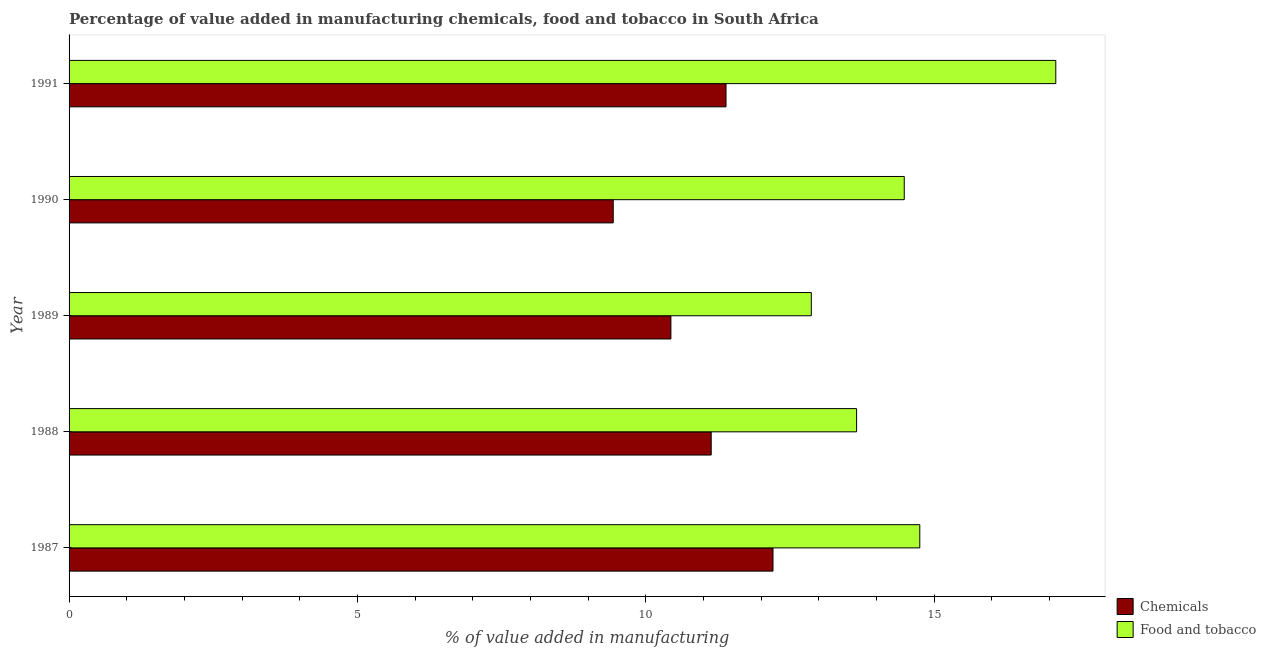How many different coloured bars are there?
Provide a succinct answer. 2. How many bars are there on the 4th tick from the bottom?
Provide a short and direct response. 2. In how many cases, is the number of bars for a given year not equal to the number of legend labels?
Provide a succinct answer. 0. What is the value added by manufacturing food and tobacco in 1989?
Offer a very short reply. 12.87. Across all years, what is the maximum value added by  manufacturing chemicals?
Keep it short and to the point. 12.21. Across all years, what is the minimum value added by  manufacturing chemicals?
Your answer should be compact. 9.44. In which year was the value added by  manufacturing chemicals maximum?
Make the answer very short. 1987. In which year was the value added by  manufacturing chemicals minimum?
Ensure brevity in your answer.  1990. What is the total value added by  manufacturing chemicals in the graph?
Your answer should be very brief. 54.6. What is the difference between the value added by  manufacturing chemicals in 1987 and that in 1989?
Your response must be concise. 1.77. What is the difference between the value added by manufacturing food and tobacco in 1988 and the value added by  manufacturing chemicals in 1991?
Make the answer very short. 2.26. What is the average value added by  manufacturing chemicals per year?
Your answer should be compact. 10.92. In the year 1991, what is the difference between the value added by manufacturing food and tobacco and value added by  manufacturing chemicals?
Your answer should be compact. 5.72. In how many years, is the value added by  manufacturing chemicals greater than 3 %?
Offer a very short reply. 5. What is the ratio of the value added by manufacturing food and tobacco in 1987 to that in 1991?
Give a very brief answer. 0.86. Is the difference between the value added by  manufacturing chemicals in 1987 and 1990 greater than the difference between the value added by manufacturing food and tobacco in 1987 and 1990?
Offer a very short reply. Yes. What is the difference between the highest and the second highest value added by manufacturing food and tobacco?
Offer a very short reply. 2.36. What is the difference between the highest and the lowest value added by manufacturing food and tobacco?
Give a very brief answer. 4.24. Is the sum of the value added by  manufacturing chemicals in 1990 and 1991 greater than the maximum value added by manufacturing food and tobacco across all years?
Provide a succinct answer. Yes. What does the 1st bar from the top in 1988 represents?
Keep it short and to the point. Food and tobacco. What does the 1st bar from the bottom in 1991 represents?
Your response must be concise. Chemicals. How many bars are there?
Make the answer very short. 10. Are all the bars in the graph horizontal?
Offer a terse response. Yes. What is the difference between two consecutive major ticks on the X-axis?
Your response must be concise. 5. Does the graph contain grids?
Provide a short and direct response. No. Where does the legend appear in the graph?
Your response must be concise. Bottom right. How are the legend labels stacked?
Your response must be concise. Vertical. What is the title of the graph?
Your response must be concise. Percentage of value added in manufacturing chemicals, food and tobacco in South Africa. What is the label or title of the X-axis?
Your response must be concise. % of value added in manufacturing. What is the % of value added in manufacturing of Chemicals in 1987?
Provide a short and direct response. 12.21. What is the % of value added in manufacturing in Food and tobacco in 1987?
Your answer should be compact. 14.75. What is the % of value added in manufacturing in Chemicals in 1988?
Provide a succinct answer. 11.13. What is the % of value added in manufacturing in Food and tobacco in 1988?
Keep it short and to the point. 13.65. What is the % of value added in manufacturing in Chemicals in 1989?
Offer a terse response. 10.43. What is the % of value added in manufacturing of Food and tobacco in 1989?
Provide a short and direct response. 12.87. What is the % of value added in manufacturing in Chemicals in 1990?
Keep it short and to the point. 9.44. What is the % of value added in manufacturing of Food and tobacco in 1990?
Provide a succinct answer. 14.48. What is the % of value added in manufacturing of Chemicals in 1991?
Ensure brevity in your answer.  11.39. What is the % of value added in manufacturing of Food and tobacco in 1991?
Ensure brevity in your answer.  17.11. Across all years, what is the maximum % of value added in manufacturing in Chemicals?
Keep it short and to the point. 12.21. Across all years, what is the maximum % of value added in manufacturing in Food and tobacco?
Your answer should be very brief. 17.11. Across all years, what is the minimum % of value added in manufacturing of Chemicals?
Offer a very short reply. 9.44. Across all years, what is the minimum % of value added in manufacturing of Food and tobacco?
Offer a very short reply. 12.87. What is the total % of value added in manufacturing of Chemicals in the graph?
Your answer should be compact. 54.6. What is the total % of value added in manufacturing in Food and tobacco in the graph?
Provide a short and direct response. 72.86. What is the difference between the % of value added in manufacturing of Chemicals in 1987 and that in 1988?
Offer a very short reply. 1.07. What is the difference between the % of value added in manufacturing in Food and tobacco in 1987 and that in 1988?
Offer a terse response. 1.1. What is the difference between the % of value added in manufacturing in Chemicals in 1987 and that in 1989?
Your answer should be compact. 1.77. What is the difference between the % of value added in manufacturing in Food and tobacco in 1987 and that in 1989?
Provide a succinct answer. 1.88. What is the difference between the % of value added in manufacturing of Chemicals in 1987 and that in 1990?
Keep it short and to the point. 2.77. What is the difference between the % of value added in manufacturing of Food and tobacco in 1987 and that in 1990?
Your answer should be very brief. 0.27. What is the difference between the % of value added in manufacturing in Chemicals in 1987 and that in 1991?
Keep it short and to the point. 0.81. What is the difference between the % of value added in manufacturing in Food and tobacco in 1987 and that in 1991?
Keep it short and to the point. -2.36. What is the difference between the % of value added in manufacturing in Chemicals in 1988 and that in 1989?
Provide a short and direct response. 0.7. What is the difference between the % of value added in manufacturing of Food and tobacco in 1988 and that in 1989?
Offer a terse response. 0.79. What is the difference between the % of value added in manufacturing in Chemicals in 1988 and that in 1990?
Offer a terse response. 1.7. What is the difference between the % of value added in manufacturing of Food and tobacco in 1988 and that in 1990?
Provide a short and direct response. -0.83. What is the difference between the % of value added in manufacturing of Chemicals in 1988 and that in 1991?
Make the answer very short. -0.26. What is the difference between the % of value added in manufacturing of Food and tobacco in 1988 and that in 1991?
Give a very brief answer. -3.45. What is the difference between the % of value added in manufacturing of Chemicals in 1989 and that in 1990?
Ensure brevity in your answer.  1. What is the difference between the % of value added in manufacturing of Food and tobacco in 1989 and that in 1990?
Offer a terse response. -1.61. What is the difference between the % of value added in manufacturing of Chemicals in 1989 and that in 1991?
Give a very brief answer. -0.96. What is the difference between the % of value added in manufacturing in Food and tobacco in 1989 and that in 1991?
Make the answer very short. -4.24. What is the difference between the % of value added in manufacturing of Chemicals in 1990 and that in 1991?
Offer a very short reply. -1.96. What is the difference between the % of value added in manufacturing of Food and tobacco in 1990 and that in 1991?
Make the answer very short. -2.63. What is the difference between the % of value added in manufacturing in Chemicals in 1987 and the % of value added in manufacturing in Food and tobacco in 1988?
Provide a short and direct response. -1.45. What is the difference between the % of value added in manufacturing of Chemicals in 1987 and the % of value added in manufacturing of Food and tobacco in 1989?
Your answer should be compact. -0.66. What is the difference between the % of value added in manufacturing of Chemicals in 1987 and the % of value added in manufacturing of Food and tobacco in 1990?
Offer a very short reply. -2.28. What is the difference between the % of value added in manufacturing of Chemicals in 1987 and the % of value added in manufacturing of Food and tobacco in 1991?
Your response must be concise. -4.9. What is the difference between the % of value added in manufacturing of Chemicals in 1988 and the % of value added in manufacturing of Food and tobacco in 1989?
Offer a very short reply. -1.74. What is the difference between the % of value added in manufacturing of Chemicals in 1988 and the % of value added in manufacturing of Food and tobacco in 1990?
Your response must be concise. -3.35. What is the difference between the % of value added in manufacturing in Chemicals in 1988 and the % of value added in manufacturing in Food and tobacco in 1991?
Keep it short and to the point. -5.97. What is the difference between the % of value added in manufacturing in Chemicals in 1989 and the % of value added in manufacturing in Food and tobacco in 1990?
Ensure brevity in your answer.  -4.05. What is the difference between the % of value added in manufacturing of Chemicals in 1989 and the % of value added in manufacturing of Food and tobacco in 1991?
Keep it short and to the point. -6.67. What is the difference between the % of value added in manufacturing of Chemicals in 1990 and the % of value added in manufacturing of Food and tobacco in 1991?
Provide a short and direct response. -7.67. What is the average % of value added in manufacturing in Chemicals per year?
Make the answer very short. 10.92. What is the average % of value added in manufacturing of Food and tobacco per year?
Provide a short and direct response. 14.57. In the year 1987, what is the difference between the % of value added in manufacturing in Chemicals and % of value added in manufacturing in Food and tobacco?
Give a very brief answer. -2.55. In the year 1988, what is the difference between the % of value added in manufacturing of Chemicals and % of value added in manufacturing of Food and tobacco?
Offer a terse response. -2.52. In the year 1989, what is the difference between the % of value added in manufacturing in Chemicals and % of value added in manufacturing in Food and tobacco?
Provide a short and direct response. -2.43. In the year 1990, what is the difference between the % of value added in manufacturing of Chemicals and % of value added in manufacturing of Food and tobacco?
Provide a short and direct response. -5.05. In the year 1991, what is the difference between the % of value added in manufacturing in Chemicals and % of value added in manufacturing in Food and tobacco?
Provide a succinct answer. -5.72. What is the ratio of the % of value added in manufacturing of Chemicals in 1987 to that in 1988?
Provide a short and direct response. 1.1. What is the ratio of the % of value added in manufacturing of Food and tobacco in 1987 to that in 1988?
Offer a very short reply. 1.08. What is the ratio of the % of value added in manufacturing in Chemicals in 1987 to that in 1989?
Give a very brief answer. 1.17. What is the ratio of the % of value added in manufacturing in Food and tobacco in 1987 to that in 1989?
Offer a terse response. 1.15. What is the ratio of the % of value added in manufacturing in Chemicals in 1987 to that in 1990?
Your response must be concise. 1.29. What is the ratio of the % of value added in manufacturing of Food and tobacco in 1987 to that in 1990?
Offer a terse response. 1.02. What is the ratio of the % of value added in manufacturing in Chemicals in 1987 to that in 1991?
Provide a succinct answer. 1.07. What is the ratio of the % of value added in manufacturing in Food and tobacco in 1987 to that in 1991?
Your response must be concise. 0.86. What is the ratio of the % of value added in manufacturing in Chemicals in 1988 to that in 1989?
Provide a short and direct response. 1.07. What is the ratio of the % of value added in manufacturing of Food and tobacco in 1988 to that in 1989?
Offer a terse response. 1.06. What is the ratio of the % of value added in manufacturing of Chemicals in 1988 to that in 1990?
Give a very brief answer. 1.18. What is the ratio of the % of value added in manufacturing of Food and tobacco in 1988 to that in 1990?
Keep it short and to the point. 0.94. What is the ratio of the % of value added in manufacturing in Chemicals in 1988 to that in 1991?
Make the answer very short. 0.98. What is the ratio of the % of value added in manufacturing in Food and tobacco in 1988 to that in 1991?
Your response must be concise. 0.8. What is the ratio of the % of value added in manufacturing of Chemicals in 1989 to that in 1990?
Your response must be concise. 1.11. What is the ratio of the % of value added in manufacturing in Food and tobacco in 1989 to that in 1990?
Offer a terse response. 0.89. What is the ratio of the % of value added in manufacturing of Chemicals in 1989 to that in 1991?
Make the answer very short. 0.92. What is the ratio of the % of value added in manufacturing in Food and tobacco in 1989 to that in 1991?
Offer a terse response. 0.75. What is the ratio of the % of value added in manufacturing in Chemicals in 1990 to that in 1991?
Offer a very short reply. 0.83. What is the ratio of the % of value added in manufacturing of Food and tobacco in 1990 to that in 1991?
Offer a very short reply. 0.85. What is the difference between the highest and the second highest % of value added in manufacturing of Chemicals?
Give a very brief answer. 0.81. What is the difference between the highest and the second highest % of value added in manufacturing of Food and tobacco?
Ensure brevity in your answer.  2.36. What is the difference between the highest and the lowest % of value added in manufacturing in Chemicals?
Your answer should be very brief. 2.77. What is the difference between the highest and the lowest % of value added in manufacturing in Food and tobacco?
Give a very brief answer. 4.24. 